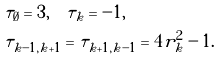<formula> <loc_0><loc_0><loc_500><loc_500>& \tau _ { \emptyset } = 3 , \quad \tau _ { k } = - 1 , \\ & \tau _ { k - 1 , k + 1 } = \tau _ { k + 1 , k - 1 } = 4 r _ { k } ^ { 2 } - 1 . \\</formula> 